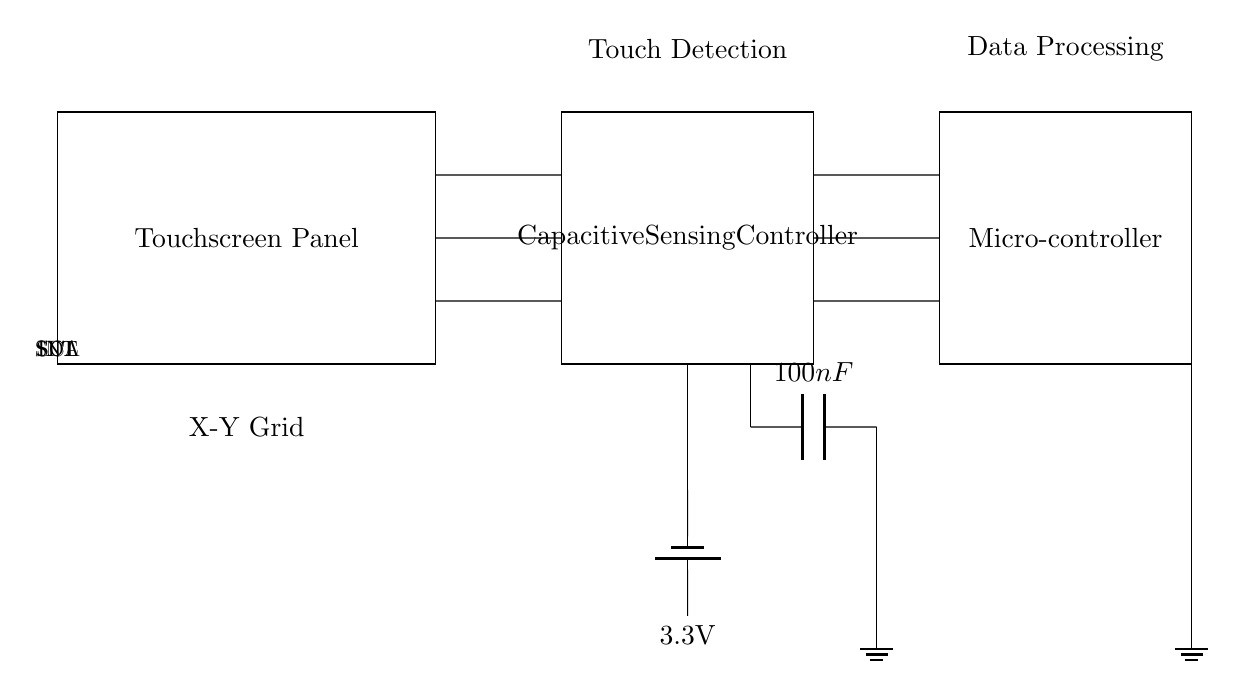What is the voltage used in the circuit? The circuit uses a battery labeled at 3.3V, which provides power to the capacitive sensing controller.
Answer: 3.3V What component is responsible for touch detection? The touchscreen panel is explicitly defined in the circuit diagram as the part responsible for detecting the touch input from the user.
Answer: Touchscreen Panel What does the INT line connect to? The INT line connects the capacitive sensing controller to the microcontroller, allowing it to notify the microcontroller when a touch is detected.
Answer: Microcontroller What is the value of the decoupling capacitor? The circuit shows a capacitor with a label of 100 nanofarads, which indicates its capacitance value, used for stabilizing the power supply to the controller.
Answer: 100nF How many connections are made between the touchscreen panel and the capacitive sensing controller? The diagram illustrates three connections from the touchscreen panel to the capacitive sensing controller at different levels for touch signals, indicating multiple data channels are used.
Answer: Three What signals are transferred between the controller and the microcontroller? The SCL and SDA lines represent the serial clock and serial data lines, respectively, allowing for data transfer in I2C communication between the two components.
Answer: SCL, SDA What is the function of the microcontroller in this circuit? The microcontroller processes the touch detection data received from the capacitive sensing controller, enabling the tablet device to interpret user interactions.
Answer: Data Processing 